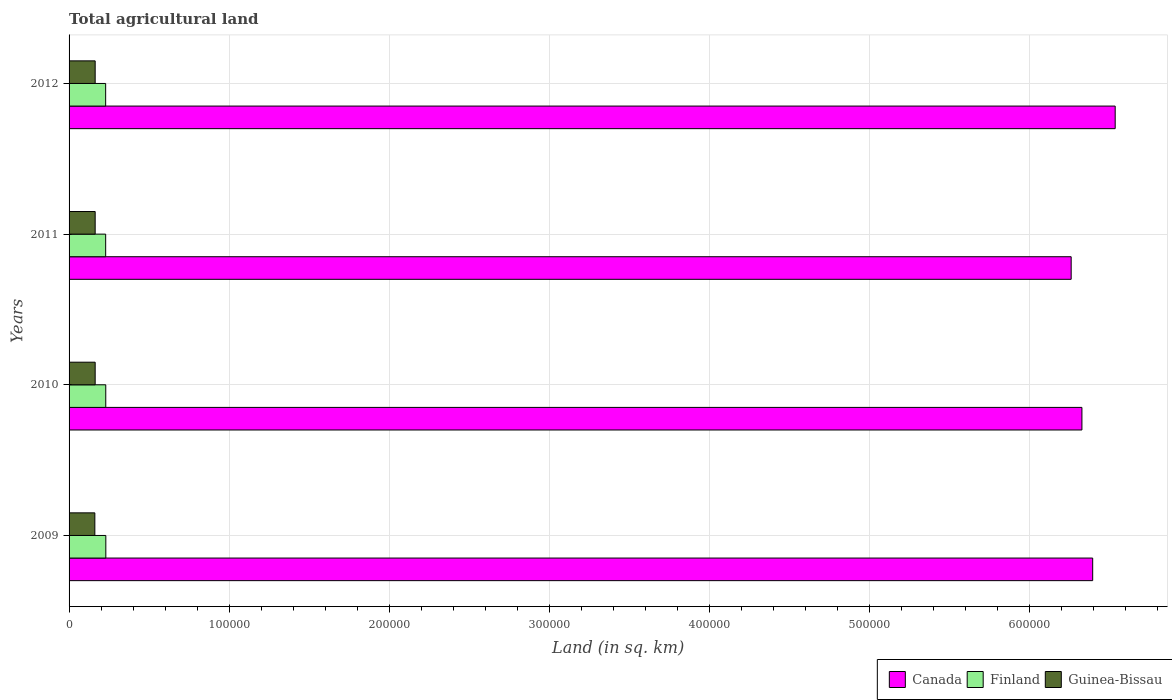Are the number of bars per tick equal to the number of legend labels?
Ensure brevity in your answer.  Yes. How many bars are there on the 2nd tick from the top?
Keep it short and to the point. 3. How many bars are there on the 1st tick from the bottom?
Offer a terse response. 3. What is the total agricultural land in Finland in 2012?
Make the answer very short. 2.29e+04. Across all years, what is the maximum total agricultural land in Finland?
Give a very brief answer. 2.30e+04. Across all years, what is the minimum total agricultural land in Canada?
Provide a short and direct response. 6.26e+05. What is the total total agricultural land in Finland in the graph?
Provide a short and direct response. 9.16e+04. What is the difference between the total agricultural land in Finland in 2011 and that in 2012?
Your answer should be compact. 15. What is the difference between the total agricultural land in Canada in 2011 and the total agricultural land in Guinea-Bissau in 2012?
Make the answer very short. 6.10e+05. What is the average total agricultural land in Finland per year?
Make the answer very short. 2.29e+04. In the year 2012, what is the difference between the total agricultural land in Guinea-Bissau and total agricultural land in Canada?
Make the answer very short. -6.37e+05. What is the ratio of the total agricultural land in Finland in 2009 to that in 2012?
Provide a succinct answer. 1. What is the difference between the highest and the second highest total agricultural land in Guinea-Bissau?
Provide a succinct answer. 0. What is the difference between the highest and the lowest total agricultural land in Guinea-Bissau?
Offer a very short reply. 200. Is the sum of the total agricultural land in Guinea-Bissau in 2011 and 2012 greater than the maximum total agricultural land in Finland across all years?
Give a very brief answer. Yes. What does the 3rd bar from the bottom in 2012 represents?
Offer a terse response. Guinea-Bissau. Is it the case that in every year, the sum of the total agricultural land in Canada and total agricultural land in Finland is greater than the total agricultural land in Guinea-Bissau?
Your answer should be compact. Yes. How many bars are there?
Offer a terse response. 12. How many years are there in the graph?
Make the answer very short. 4. Does the graph contain any zero values?
Provide a short and direct response. No. Does the graph contain grids?
Provide a succinct answer. Yes. Where does the legend appear in the graph?
Give a very brief answer. Bottom right. How are the legend labels stacked?
Offer a very short reply. Horizontal. What is the title of the graph?
Keep it short and to the point. Total agricultural land. What is the label or title of the X-axis?
Offer a very short reply. Land (in sq. km). What is the Land (in sq. km) in Canada in 2009?
Your answer should be compact. 6.39e+05. What is the Land (in sq. km) in Finland in 2009?
Offer a terse response. 2.30e+04. What is the Land (in sq. km) in Guinea-Bissau in 2009?
Provide a short and direct response. 1.61e+04. What is the Land (in sq. km) in Canada in 2010?
Ensure brevity in your answer.  6.33e+05. What is the Land (in sq. km) of Finland in 2010?
Ensure brevity in your answer.  2.29e+04. What is the Land (in sq. km) of Guinea-Bissau in 2010?
Your answer should be very brief. 1.63e+04. What is the Land (in sq. km) in Canada in 2011?
Offer a very short reply. 6.26e+05. What is the Land (in sq. km) of Finland in 2011?
Provide a succinct answer. 2.29e+04. What is the Land (in sq. km) in Guinea-Bissau in 2011?
Keep it short and to the point. 1.63e+04. What is the Land (in sq. km) of Canada in 2012?
Your answer should be very brief. 6.53e+05. What is the Land (in sq. km) of Finland in 2012?
Keep it short and to the point. 2.29e+04. What is the Land (in sq. km) of Guinea-Bissau in 2012?
Your response must be concise. 1.63e+04. Across all years, what is the maximum Land (in sq. km) of Canada?
Make the answer very short. 6.53e+05. Across all years, what is the maximum Land (in sq. km) of Finland?
Offer a terse response. 2.30e+04. Across all years, what is the maximum Land (in sq. km) of Guinea-Bissau?
Your answer should be very brief. 1.63e+04. Across all years, what is the minimum Land (in sq. km) in Canada?
Provide a succinct answer. 6.26e+05. Across all years, what is the minimum Land (in sq. km) of Finland?
Keep it short and to the point. 2.29e+04. Across all years, what is the minimum Land (in sq. km) in Guinea-Bissau?
Give a very brief answer. 1.61e+04. What is the total Land (in sq. km) in Canada in the graph?
Your answer should be compact. 2.55e+06. What is the total Land (in sq. km) in Finland in the graph?
Ensure brevity in your answer.  9.16e+04. What is the total Land (in sq. km) in Guinea-Bissau in the graph?
Provide a short and direct response. 6.50e+04. What is the difference between the Land (in sq. km) in Canada in 2009 and that in 2010?
Keep it short and to the point. 6716. What is the difference between the Land (in sq. km) of Finland in 2009 and that in 2010?
Offer a terse response. 46. What is the difference between the Land (in sq. km) of Guinea-Bissau in 2009 and that in 2010?
Offer a very short reply. -200. What is the difference between the Land (in sq. km) in Canada in 2009 and that in 2011?
Provide a short and direct response. 1.34e+04. What is the difference between the Land (in sq. km) in Finland in 2009 and that in 2011?
Offer a terse response. 99. What is the difference between the Land (in sq. km) in Guinea-Bissau in 2009 and that in 2011?
Give a very brief answer. -200. What is the difference between the Land (in sq. km) of Canada in 2009 and that in 2012?
Make the answer very short. -1.41e+04. What is the difference between the Land (in sq. km) of Finland in 2009 and that in 2012?
Make the answer very short. 114. What is the difference between the Land (in sq. km) in Guinea-Bissau in 2009 and that in 2012?
Your answer should be compact. -200. What is the difference between the Land (in sq. km) of Canada in 2010 and that in 2011?
Make the answer very short. 6716. What is the difference between the Land (in sq. km) of Finland in 2010 and that in 2011?
Ensure brevity in your answer.  53. What is the difference between the Land (in sq. km) in Guinea-Bissau in 2010 and that in 2011?
Ensure brevity in your answer.  0. What is the difference between the Land (in sq. km) in Canada in 2010 and that in 2012?
Provide a succinct answer. -2.08e+04. What is the difference between the Land (in sq. km) of Finland in 2010 and that in 2012?
Your answer should be very brief. 68. What is the difference between the Land (in sq. km) in Canada in 2011 and that in 2012?
Provide a succinct answer. -2.75e+04. What is the difference between the Land (in sq. km) of Finland in 2011 and that in 2012?
Your answer should be compact. 15. What is the difference between the Land (in sq. km) in Canada in 2009 and the Land (in sq. km) in Finland in 2010?
Provide a succinct answer. 6.16e+05. What is the difference between the Land (in sq. km) of Canada in 2009 and the Land (in sq. km) of Guinea-Bissau in 2010?
Your response must be concise. 6.23e+05. What is the difference between the Land (in sq. km) in Finland in 2009 and the Land (in sq. km) in Guinea-Bissau in 2010?
Ensure brevity in your answer.  6665. What is the difference between the Land (in sq. km) in Canada in 2009 and the Land (in sq. km) in Finland in 2011?
Keep it short and to the point. 6.17e+05. What is the difference between the Land (in sq. km) in Canada in 2009 and the Land (in sq. km) in Guinea-Bissau in 2011?
Provide a short and direct response. 6.23e+05. What is the difference between the Land (in sq. km) of Finland in 2009 and the Land (in sq. km) of Guinea-Bissau in 2011?
Keep it short and to the point. 6665. What is the difference between the Land (in sq. km) of Canada in 2009 and the Land (in sq. km) of Finland in 2012?
Give a very brief answer. 6.17e+05. What is the difference between the Land (in sq. km) in Canada in 2009 and the Land (in sq. km) in Guinea-Bissau in 2012?
Keep it short and to the point. 6.23e+05. What is the difference between the Land (in sq. km) in Finland in 2009 and the Land (in sq. km) in Guinea-Bissau in 2012?
Your answer should be compact. 6665. What is the difference between the Land (in sq. km) of Canada in 2010 and the Land (in sq. km) of Finland in 2011?
Your answer should be compact. 6.10e+05. What is the difference between the Land (in sq. km) of Canada in 2010 and the Land (in sq. km) of Guinea-Bissau in 2011?
Ensure brevity in your answer.  6.16e+05. What is the difference between the Land (in sq. km) in Finland in 2010 and the Land (in sq. km) in Guinea-Bissau in 2011?
Give a very brief answer. 6619. What is the difference between the Land (in sq. km) in Canada in 2010 and the Land (in sq. km) in Finland in 2012?
Give a very brief answer. 6.10e+05. What is the difference between the Land (in sq. km) of Canada in 2010 and the Land (in sq. km) of Guinea-Bissau in 2012?
Your answer should be compact. 6.16e+05. What is the difference between the Land (in sq. km) of Finland in 2010 and the Land (in sq. km) of Guinea-Bissau in 2012?
Provide a short and direct response. 6619. What is the difference between the Land (in sq. km) of Canada in 2011 and the Land (in sq. km) of Finland in 2012?
Ensure brevity in your answer.  6.03e+05. What is the difference between the Land (in sq. km) in Canada in 2011 and the Land (in sq. km) in Guinea-Bissau in 2012?
Keep it short and to the point. 6.10e+05. What is the difference between the Land (in sq. km) of Finland in 2011 and the Land (in sq. km) of Guinea-Bissau in 2012?
Offer a terse response. 6566. What is the average Land (in sq. km) of Canada per year?
Offer a terse response. 6.38e+05. What is the average Land (in sq. km) in Finland per year?
Ensure brevity in your answer.  2.29e+04. What is the average Land (in sq. km) in Guinea-Bissau per year?
Your response must be concise. 1.62e+04. In the year 2009, what is the difference between the Land (in sq. km) in Canada and Land (in sq. km) in Finland?
Your answer should be very brief. 6.16e+05. In the year 2009, what is the difference between the Land (in sq. km) of Canada and Land (in sq. km) of Guinea-Bissau?
Give a very brief answer. 6.23e+05. In the year 2009, what is the difference between the Land (in sq. km) in Finland and Land (in sq. km) in Guinea-Bissau?
Your response must be concise. 6865. In the year 2010, what is the difference between the Land (in sq. km) in Canada and Land (in sq. km) in Finland?
Offer a terse response. 6.10e+05. In the year 2010, what is the difference between the Land (in sq. km) in Canada and Land (in sq. km) in Guinea-Bissau?
Ensure brevity in your answer.  6.16e+05. In the year 2010, what is the difference between the Land (in sq. km) of Finland and Land (in sq. km) of Guinea-Bissau?
Provide a short and direct response. 6619. In the year 2011, what is the difference between the Land (in sq. km) in Canada and Land (in sq. km) in Finland?
Your response must be concise. 6.03e+05. In the year 2011, what is the difference between the Land (in sq. km) of Canada and Land (in sq. km) of Guinea-Bissau?
Provide a succinct answer. 6.10e+05. In the year 2011, what is the difference between the Land (in sq. km) of Finland and Land (in sq. km) of Guinea-Bissau?
Make the answer very short. 6566. In the year 2012, what is the difference between the Land (in sq. km) of Canada and Land (in sq. km) of Finland?
Your response must be concise. 6.31e+05. In the year 2012, what is the difference between the Land (in sq. km) of Canada and Land (in sq. km) of Guinea-Bissau?
Ensure brevity in your answer.  6.37e+05. In the year 2012, what is the difference between the Land (in sq. km) of Finland and Land (in sq. km) of Guinea-Bissau?
Offer a very short reply. 6551. What is the ratio of the Land (in sq. km) of Canada in 2009 to that in 2010?
Your answer should be very brief. 1.01. What is the ratio of the Land (in sq. km) of Guinea-Bissau in 2009 to that in 2010?
Offer a terse response. 0.99. What is the ratio of the Land (in sq. km) of Canada in 2009 to that in 2011?
Give a very brief answer. 1.02. What is the ratio of the Land (in sq. km) of Canada in 2009 to that in 2012?
Your response must be concise. 0.98. What is the ratio of the Land (in sq. km) of Finland in 2009 to that in 2012?
Your answer should be very brief. 1. What is the ratio of the Land (in sq. km) in Guinea-Bissau in 2009 to that in 2012?
Offer a terse response. 0.99. What is the ratio of the Land (in sq. km) of Canada in 2010 to that in 2011?
Provide a short and direct response. 1.01. What is the ratio of the Land (in sq. km) of Canada in 2010 to that in 2012?
Make the answer very short. 0.97. What is the ratio of the Land (in sq. km) in Guinea-Bissau in 2010 to that in 2012?
Provide a short and direct response. 1. What is the ratio of the Land (in sq. km) in Canada in 2011 to that in 2012?
Your answer should be compact. 0.96. What is the ratio of the Land (in sq. km) in Finland in 2011 to that in 2012?
Ensure brevity in your answer.  1. What is the ratio of the Land (in sq. km) in Guinea-Bissau in 2011 to that in 2012?
Offer a very short reply. 1. What is the difference between the highest and the second highest Land (in sq. km) in Canada?
Your answer should be very brief. 1.41e+04. What is the difference between the highest and the second highest Land (in sq. km) of Finland?
Your answer should be very brief. 46. What is the difference between the highest and the lowest Land (in sq. km) of Canada?
Your response must be concise. 2.75e+04. What is the difference between the highest and the lowest Land (in sq. km) in Finland?
Give a very brief answer. 114. 